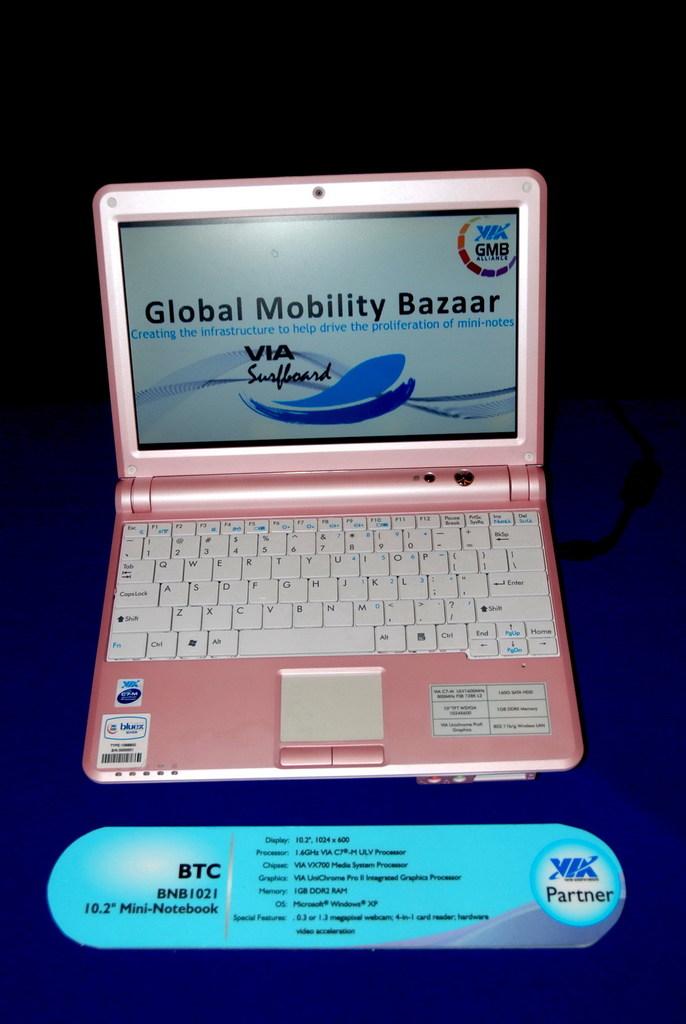What does the screen say?
Give a very brief answer. Global mobility bazaar. What kind of processor?
Make the answer very short. Intel. 